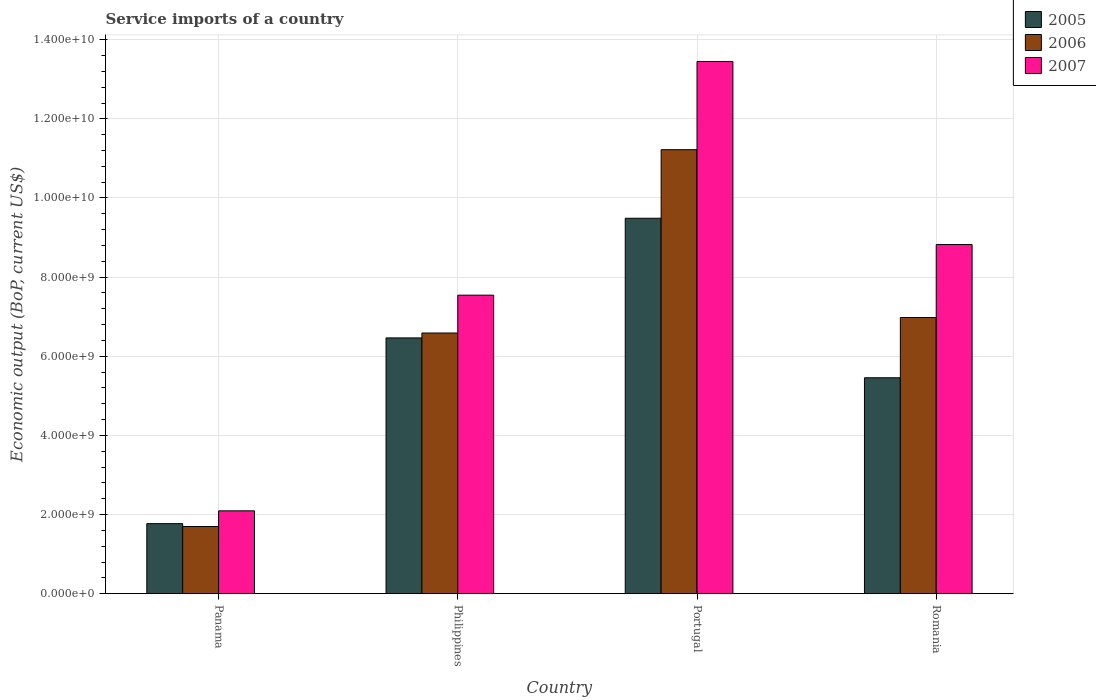How many different coloured bars are there?
Give a very brief answer. 3. How many groups of bars are there?
Keep it short and to the point. 4. Are the number of bars on each tick of the X-axis equal?
Keep it short and to the point. Yes. How many bars are there on the 1st tick from the right?
Provide a succinct answer. 3. What is the label of the 2nd group of bars from the left?
Your response must be concise. Philippines. What is the service imports in 2005 in Philippines?
Offer a terse response. 6.46e+09. Across all countries, what is the maximum service imports in 2005?
Provide a short and direct response. 9.49e+09. Across all countries, what is the minimum service imports in 2006?
Offer a terse response. 1.70e+09. In which country was the service imports in 2005 minimum?
Provide a succinct answer. Panama. What is the total service imports in 2007 in the graph?
Provide a succinct answer. 3.19e+1. What is the difference between the service imports in 2006 in Philippines and that in Portugal?
Make the answer very short. -4.63e+09. What is the difference between the service imports in 2006 in Panama and the service imports in 2007 in Portugal?
Provide a short and direct response. -1.18e+1. What is the average service imports in 2007 per country?
Your answer should be very brief. 7.98e+09. What is the difference between the service imports of/in 2007 and service imports of/in 2005 in Portugal?
Provide a short and direct response. 3.96e+09. In how many countries, is the service imports in 2005 greater than 5200000000 US$?
Offer a very short reply. 3. What is the ratio of the service imports in 2007 in Panama to that in Portugal?
Make the answer very short. 0.16. Is the service imports in 2006 in Philippines less than that in Romania?
Provide a succinct answer. Yes. What is the difference between the highest and the second highest service imports in 2005?
Offer a terse response. 3.02e+09. What is the difference between the highest and the lowest service imports in 2006?
Provide a short and direct response. 9.52e+09. In how many countries, is the service imports in 2006 greater than the average service imports in 2006 taken over all countries?
Provide a short and direct response. 2. Is the sum of the service imports in 2007 in Philippines and Portugal greater than the maximum service imports in 2005 across all countries?
Keep it short and to the point. Yes. What does the 1st bar from the right in Romania represents?
Make the answer very short. 2007. Are all the bars in the graph horizontal?
Make the answer very short. No. How many countries are there in the graph?
Provide a short and direct response. 4. What is the difference between two consecutive major ticks on the Y-axis?
Your answer should be compact. 2.00e+09. Are the values on the major ticks of Y-axis written in scientific E-notation?
Your answer should be very brief. Yes. Does the graph contain any zero values?
Your answer should be very brief. No. Where does the legend appear in the graph?
Ensure brevity in your answer.  Top right. What is the title of the graph?
Offer a terse response. Service imports of a country. Does "1977" appear as one of the legend labels in the graph?
Your answer should be compact. No. What is the label or title of the Y-axis?
Your response must be concise. Economic output (BoP, current US$). What is the Economic output (BoP, current US$) in 2005 in Panama?
Provide a short and direct response. 1.77e+09. What is the Economic output (BoP, current US$) in 2006 in Panama?
Give a very brief answer. 1.70e+09. What is the Economic output (BoP, current US$) of 2007 in Panama?
Offer a very short reply. 2.09e+09. What is the Economic output (BoP, current US$) in 2005 in Philippines?
Offer a terse response. 6.46e+09. What is the Economic output (BoP, current US$) of 2006 in Philippines?
Your answer should be compact. 6.59e+09. What is the Economic output (BoP, current US$) of 2007 in Philippines?
Give a very brief answer. 7.54e+09. What is the Economic output (BoP, current US$) in 2005 in Portugal?
Your answer should be very brief. 9.49e+09. What is the Economic output (BoP, current US$) in 2006 in Portugal?
Provide a succinct answer. 1.12e+1. What is the Economic output (BoP, current US$) in 2007 in Portugal?
Your response must be concise. 1.34e+1. What is the Economic output (BoP, current US$) in 2005 in Romania?
Offer a terse response. 5.46e+09. What is the Economic output (BoP, current US$) in 2006 in Romania?
Offer a terse response. 6.98e+09. What is the Economic output (BoP, current US$) in 2007 in Romania?
Make the answer very short. 8.82e+09. Across all countries, what is the maximum Economic output (BoP, current US$) of 2005?
Make the answer very short. 9.49e+09. Across all countries, what is the maximum Economic output (BoP, current US$) of 2006?
Keep it short and to the point. 1.12e+1. Across all countries, what is the maximum Economic output (BoP, current US$) in 2007?
Your answer should be very brief. 1.34e+1. Across all countries, what is the minimum Economic output (BoP, current US$) in 2005?
Offer a very short reply. 1.77e+09. Across all countries, what is the minimum Economic output (BoP, current US$) in 2006?
Give a very brief answer. 1.70e+09. Across all countries, what is the minimum Economic output (BoP, current US$) of 2007?
Make the answer very short. 2.09e+09. What is the total Economic output (BoP, current US$) in 2005 in the graph?
Your response must be concise. 2.32e+1. What is the total Economic output (BoP, current US$) of 2006 in the graph?
Provide a succinct answer. 2.65e+1. What is the total Economic output (BoP, current US$) in 2007 in the graph?
Offer a very short reply. 3.19e+1. What is the difference between the Economic output (BoP, current US$) of 2005 in Panama and that in Philippines?
Make the answer very short. -4.69e+09. What is the difference between the Economic output (BoP, current US$) in 2006 in Panama and that in Philippines?
Offer a very short reply. -4.89e+09. What is the difference between the Economic output (BoP, current US$) of 2007 in Panama and that in Philippines?
Ensure brevity in your answer.  -5.45e+09. What is the difference between the Economic output (BoP, current US$) in 2005 in Panama and that in Portugal?
Provide a short and direct response. -7.72e+09. What is the difference between the Economic output (BoP, current US$) in 2006 in Panama and that in Portugal?
Your answer should be very brief. -9.52e+09. What is the difference between the Economic output (BoP, current US$) in 2007 in Panama and that in Portugal?
Make the answer very short. -1.14e+1. What is the difference between the Economic output (BoP, current US$) in 2005 in Panama and that in Romania?
Provide a short and direct response. -3.69e+09. What is the difference between the Economic output (BoP, current US$) in 2006 in Panama and that in Romania?
Your answer should be very brief. -5.28e+09. What is the difference between the Economic output (BoP, current US$) of 2007 in Panama and that in Romania?
Your answer should be compact. -6.73e+09. What is the difference between the Economic output (BoP, current US$) of 2005 in Philippines and that in Portugal?
Your answer should be very brief. -3.02e+09. What is the difference between the Economic output (BoP, current US$) of 2006 in Philippines and that in Portugal?
Provide a succinct answer. -4.63e+09. What is the difference between the Economic output (BoP, current US$) in 2007 in Philippines and that in Portugal?
Keep it short and to the point. -5.91e+09. What is the difference between the Economic output (BoP, current US$) in 2005 in Philippines and that in Romania?
Ensure brevity in your answer.  1.01e+09. What is the difference between the Economic output (BoP, current US$) in 2006 in Philippines and that in Romania?
Make the answer very short. -3.92e+08. What is the difference between the Economic output (BoP, current US$) of 2007 in Philippines and that in Romania?
Ensure brevity in your answer.  -1.28e+09. What is the difference between the Economic output (BoP, current US$) of 2005 in Portugal and that in Romania?
Your response must be concise. 4.03e+09. What is the difference between the Economic output (BoP, current US$) of 2006 in Portugal and that in Romania?
Offer a terse response. 4.24e+09. What is the difference between the Economic output (BoP, current US$) of 2007 in Portugal and that in Romania?
Your response must be concise. 4.63e+09. What is the difference between the Economic output (BoP, current US$) in 2005 in Panama and the Economic output (BoP, current US$) in 2006 in Philippines?
Provide a succinct answer. -4.82e+09. What is the difference between the Economic output (BoP, current US$) of 2005 in Panama and the Economic output (BoP, current US$) of 2007 in Philippines?
Offer a very short reply. -5.77e+09. What is the difference between the Economic output (BoP, current US$) in 2006 in Panama and the Economic output (BoP, current US$) in 2007 in Philippines?
Keep it short and to the point. -5.85e+09. What is the difference between the Economic output (BoP, current US$) in 2005 in Panama and the Economic output (BoP, current US$) in 2006 in Portugal?
Keep it short and to the point. -9.45e+09. What is the difference between the Economic output (BoP, current US$) of 2005 in Panama and the Economic output (BoP, current US$) of 2007 in Portugal?
Provide a short and direct response. -1.17e+1. What is the difference between the Economic output (BoP, current US$) of 2006 in Panama and the Economic output (BoP, current US$) of 2007 in Portugal?
Offer a very short reply. -1.18e+1. What is the difference between the Economic output (BoP, current US$) in 2005 in Panama and the Economic output (BoP, current US$) in 2006 in Romania?
Your answer should be very brief. -5.21e+09. What is the difference between the Economic output (BoP, current US$) of 2005 in Panama and the Economic output (BoP, current US$) of 2007 in Romania?
Offer a very short reply. -7.05e+09. What is the difference between the Economic output (BoP, current US$) in 2006 in Panama and the Economic output (BoP, current US$) in 2007 in Romania?
Ensure brevity in your answer.  -7.13e+09. What is the difference between the Economic output (BoP, current US$) in 2005 in Philippines and the Economic output (BoP, current US$) in 2006 in Portugal?
Your answer should be compact. -4.76e+09. What is the difference between the Economic output (BoP, current US$) in 2005 in Philippines and the Economic output (BoP, current US$) in 2007 in Portugal?
Offer a terse response. -6.99e+09. What is the difference between the Economic output (BoP, current US$) of 2006 in Philippines and the Economic output (BoP, current US$) of 2007 in Portugal?
Your answer should be compact. -6.86e+09. What is the difference between the Economic output (BoP, current US$) in 2005 in Philippines and the Economic output (BoP, current US$) in 2006 in Romania?
Provide a succinct answer. -5.16e+08. What is the difference between the Economic output (BoP, current US$) of 2005 in Philippines and the Economic output (BoP, current US$) of 2007 in Romania?
Provide a succinct answer. -2.36e+09. What is the difference between the Economic output (BoP, current US$) in 2006 in Philippines and the Economic output (BoP, current US$) in 2007 in Romania?
Keep it short and to the point. -2.24e+09. What is the difference between the Economic output (BoP, current US$) of 2005 in Portugal and the Economic output (BoP, current US$) of 2006 in Romania?
Offer a terse response. 2.51e+09. What is the difference between the Economic output (BoP, current US$) in 2005 in Portugal and the Economic output (BoP, current US$) in 2007 in Romania?
Offer a very short reply. 6.64e+08. What is the difference between the Economic output (BoP, current US$) in 2006 in Portugal and the Economic output (BoP, current US$) in 2007 in Romania?
Your answer should be compact. 2.40e+09. What is the average Economic output (BoP, current US$) in 2005 per country?
Make the answer very short. 5.79e+09. What is the average Economic output (BoP, current US$) in 2006 per country?
Make the answer very short. 6.62e+09. What is the average Economic output (BoP, current US$) of 2007 per country?
Give a very brief answer. 7.98e+09. What is the difference between the Economic output (BoP, current US$) of 2005 and Economic output (BoP, current US$) of 2006 in Panama?
Ensure brevity in your answer.  7.32e+07. What is the difference between the Economic output (BoP, current US$) in 2005 and Economic output (BoP, current US$) in 2007 in Panama?
Ensure brevity in your answer.  -3.24e+08. What is the difference between the Economic output (BoP, current US$) in 2006 and Economic output (BoP, current US$) in 2007 in Panama?
Offer a terse response. -3.97e+08. What is the difference between the Economic output (BoP, current US$) in 2005 and Economic output (BoP, current US$) in 2006 in Philippines?
Your answer should be very brief. -1.24e+08. What is the difference between the Economic output (BoP, current US$) of 2005 and Economic output (BoP, current US$) of 2007 in Philippines?
Your answer should be very brief. -1.08e+09. What is the difference between the Economic output (BoP, current US$) in 2006 and Economic output (BoP, current US$) in 2007 in Philippines?
Give a very brief answer. -9.56e+08. What is the difference between the Economic output (BoP, current US$) in 2005 and Economic output (BoP, current US$) in 2006 in Portugal?
Provide a short and direct response. -1.73e+09. What is the difference between the Economic output (BoP, current US$) in 2005 and Economic output (BoP, current US$) in 2007 in Portugal?
Provide a succinct answer. -3.96e+09. What is the difference between the Economic output (BoP, current US$) of 2006 and Economic output (BoP, current US$) of 2007 in Portugal?
Your answer should be very brief. -2.23e+09. What is the difference between the Economic output (BoP, current US$) of 2005 and Economic output (BoP, current US$) of 2006 in Romania?
Your answer should be compact. -1.52e+09. What is the difference between the Economic output (BoP, current US$) of 2005 and Economic output (BoP, current US$) of 2007 in Romania?
Ensure brevity in your answer.  -3.37e+09. What is the difference between the Economic output (BoP, current US$) of 2006 and Economic output (BoP, current US$) of 2007 in Romania?
Offer a very short reply. -1.84e+09. What is the ratio of the Economic output (BoP, current US$) in 2005 in Panama to that in Philippines?
Offer a terse response. 0.27. What is the ratio of the Economic output (BoP, current US$) of 2006 in Panama to that in Philippines?
Offer a very short reply. 0.26. What is the ratio of the Economic output (BoP, current US$) in 2007 in Panama to that in Philippines?
Offer a very short reply. 0.28. What is the ratio of the Economic output (BoP, current US$) of 2005 in Panama to that in Portugal?
Offer a terse response. 0.19. What is the ratio of the Economic output (BoP, current US$) in 2006 in Panama to that in Portugal?
Give a very brief answer. 0.15. What is the ratio of the Economic output (BoP, current US$) of 2007 in Panama to that in Portugal?
Your answer should be very brief. 0.16. What is the ratio of the Economic output (BoP, current US$) of 2005 in Panama to that in Romania?
Your answer should be very brief. 0.32. What is the ratio of the Economic output (BoP, current US$) of 2006 in Panama to that in Romania?
Keep it short and to the point. 0.24. What is the ratio of the Economic output (BoP, current US$) of 2007 in Panama to that in Romania?
Keep it short and to the point. 0.24. What is the ratio of the Economic output (BoP, current US$) in 2005 in Philippines to that in Portugal?
Offer a very short reply. 0.68. What is the ratio of the Economic output (BoP, current US$) in 2006 in Philippines to that in Portugal?
Your answer should be compact. 0.59. What is the ratio of the Economic output (BoP, current US$) of 2007 in Philippines to that in Portugal?
Offer a very short reply. 0.56. What is the ratio of the Economic output (BoP, current US$) of 2005 in Philippines to that in Romania?
Give a very brief answer. 1.18. What is the ratio of the Economic output (BoP, current US$) of 2006 in Philippines to that in Romania?
Offer a terse response. 0.94. What is the ratio of the Economic output (BoP, current US$) of 2007 in Philippines to that in Romania?
Ensure brevity in your answer.  0.85. What is the ratio of the Economic output (BoP, current US$) in 2005 in Portugal to that in Romania?
Give a very brief answer. 1.74. What is the ratio of the Economic output (BoP, current US$) of 2006 in Portugal to that in Romania?
Your answer should be very brief. 1.61. What is the ratio of the Economic output (BoP, current US$) of 2007 in Portugal to that in Romania?
Give a very brief answer. 1.52. What is the difference between the highest and the second highest Economic output (BoP, current US$) in 2005?
Your answer should be very brief. 3.02e+09. What is the difference between the highest and the second highest Economic output (BoP, current US$) in 2006?
Your answer should be very brief. 4.24e+09. What is the difference between the highest and the second highest Economic output (BoP, current US$) in 2007?
Your response must be concise. 4.63e+09. What is the difference between the highest and the lowest Economic output (BoP, current US$) of 2005?
Provide a short and direct response. 7.72e+09. What is the difference between the highest and the lowest Economic output (BoP, current US$) of 2006?
Ensure brevity in your answer.  9.52e+09. What is the difference between the highest and the lowest Economic output (BoP, current US$) of 2007?
Make the answer very short. 1.14e+1. 